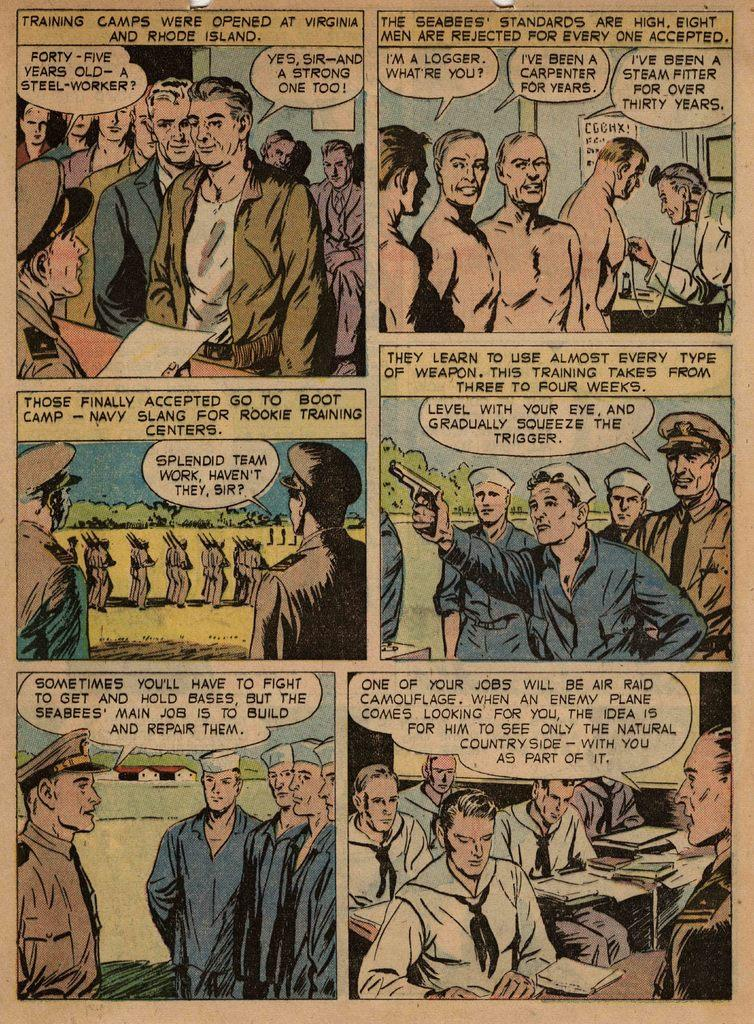<image>
Render a clear and concise summary of the photo. A man tells two other men that he is a logger. 